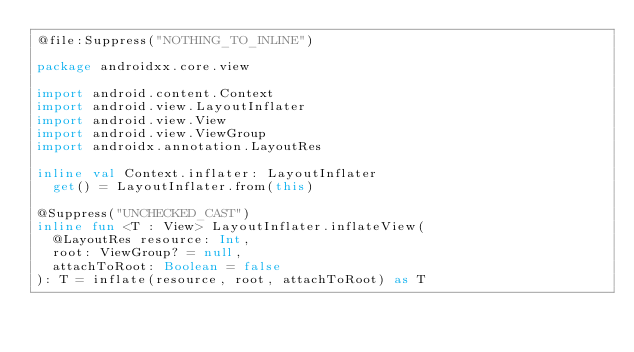Convert code to text. <code><loc_0><loc_0><loc_500><loc_500><_Kotlin_>@file:Suppress("NOTHING_TO_INLINE")

package androidxx.core.view

import android.content.Context
import android.view.LayoutInflater
import android.view.View
import android.view.ViewGroup
import androidx.annotation.LayoutRes

inline val Context.inflater: LayoutInflater
  get() = LayoutInflater.from(this)

@Suppress("UNCHECKED_CAST")
inline fun <T : View> LayoutInflater.inflateView(
  @LayoutRes resource: Int,
  root: ViewGroup? = null,
  attachToRoot: Boolean = false
): T = inflate(resource, root, attachToRoot) as T</code> 